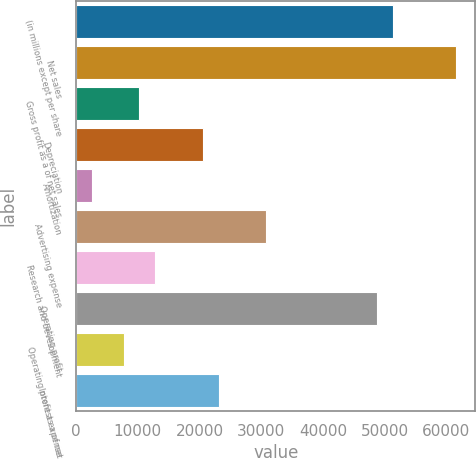<chart> <loc_0><loc_0><loc_500><loc_500><bar_chart><fcel>(in millions except per share<fcel>Net sales<fcel>Gross profit as a of net sales<fcel>Depreciation<fcel>Amortization<fcel>Advertising expense<fcel>Research and development<fcel>Operating profit<fcel>Operating profit as a of net<fcel>Interest expense<nl><fcel>51351<fcel>61621<fcel>10271<fcel>20541<fcel>2568.51<fcel>30811<fcel>12838.5<fcel>48783.5<fcel>7703.51<fcel>23108.5<nl></chart> 